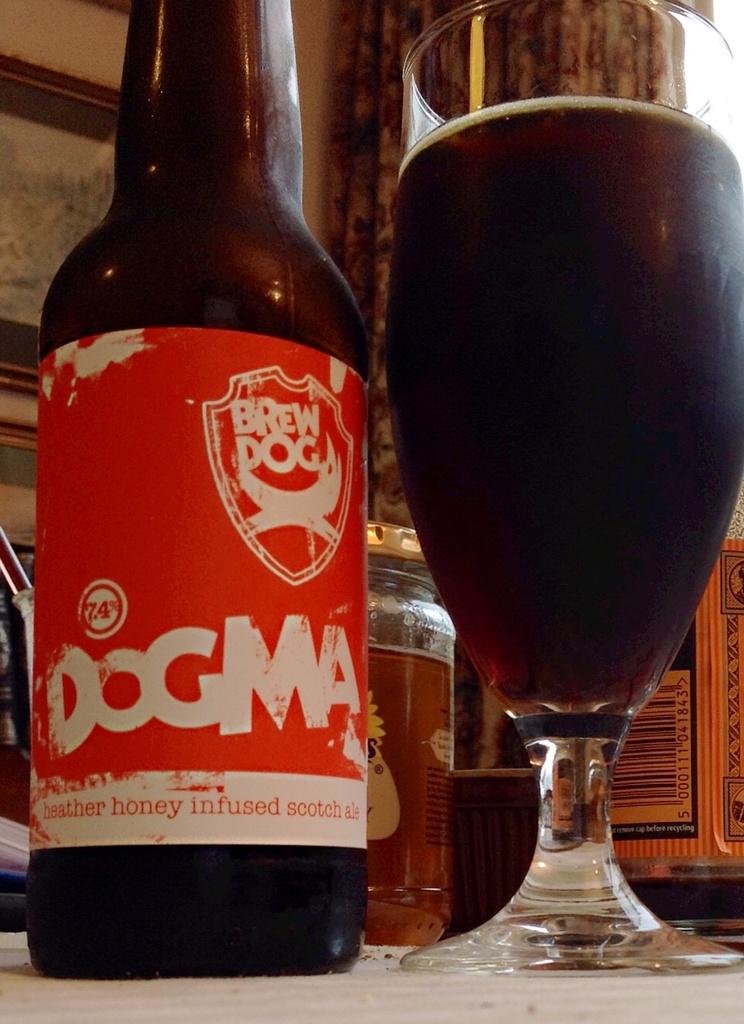What brand is this beer?
Offer a very short reply. Dogma. 